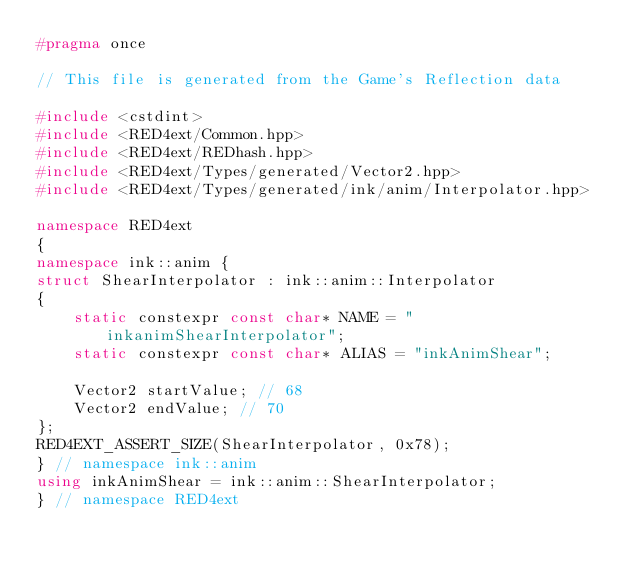<code> <loc_0><loc_0><loc_500><loc_500><_C++_>#pragma once

// This file is generated from the Game's Reflection data

#include <cstdint>
#include <RED4ext/Common.hpp>
#include <RED4ext/REDhash.hpp>
#include <RED4ext/Types/generated/Vector2.hpp>
#include <RED4ext/Types/generated/ink/anim/Interpolator.hpp>

namespace RED4ext
{
namespace ink::anim { 
struct ShearInterpolator : ink::anim::Interpolator
{
    static constexpr const char* NAME = "inkanimShearInterpolator";
    static constexpr const char* ALIAS = "inkAnimShear";

    Vector2 startValue; // 68
    Vector2 endValue; // 70
};
RED4EXT_ASSERT_SIZE(ShearInterpolator, 0x78);
} // namespace ink::anim
using inkAnimShear = ink::anim::ShearInterpolator;
} // namespace RED4ext
</code> 